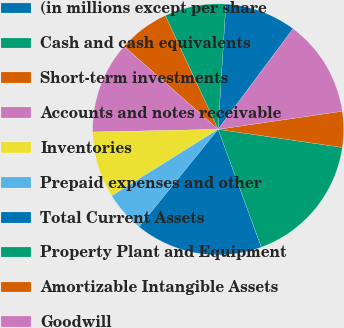Convert chart. <chart><loc_0><loc_0><loc_500><loc_500><pie_chart><fcel>(in millions except per share<fcel>Cash and cash equivalents<fcel>Short-term investments<fcel>Accounts and notes receivable<fcel>Inventories<fcel>Prepaid expenses and other<fcel>Total Current Assets<fcel>Property Plant and Equipment<fcel>Amortizable Intangible Assets<fcel>Goodwill<nl><fcel>9.21%<fcel>7.9%<fcel>6.58%<fcel>11.84%<fcel>8.55%<fcel>5.27%<fcel>16.44%<fcel>17.1%<fcel>4.61%<fcel>12.5%<nl></chart> 